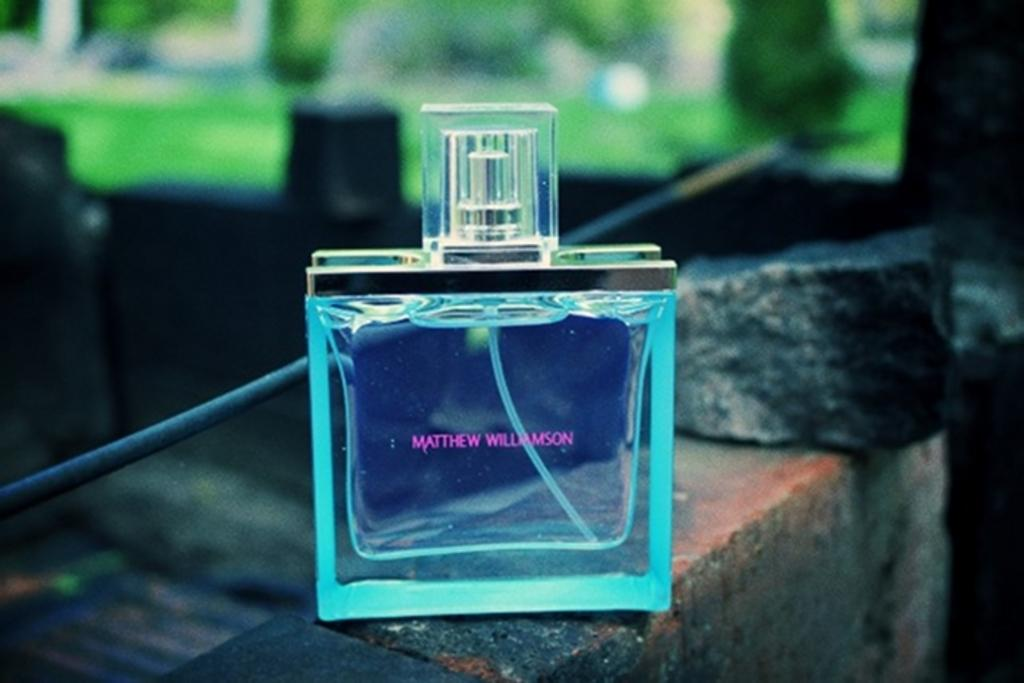What is the main object in the image? There is a perfume in the image. What can be seen on the wall in the image? There is a stone on the wall in the image. What might be visible in the background of the image? There may be trees and grass in the background of the image. What is the material of the small rod near the wall? There is a small metal rod near the wall in the image. What is the name of the nation that the watch in the image belongs to? There is no watch present in the image, so it is not possible to determine the name of the nation it might belong to. 